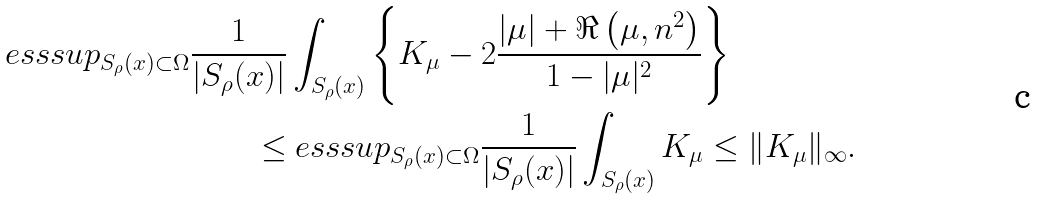<formula> <loc_0><loc_0><loc_500><loc_500>\ e s s s u p _ { S _ { \rho } ( x ) \subset \Omega } \frac { 1 } { | S _ { \rho } ( x ) | } & \int _ { S _ { \rho } ( x ) } \left \{ K _ { \mu } - 2 \frac { | \mu | + \Re \left ( \mu , n ^ { 2 } \right ) } { 1 - | \mu | ^ { 2 } } \right \} \\ \leq & \ e s s s u p _ { S _ { \rho } ( x ) \subset \Omega } \frac { 1 } { | S _ { \rho } ( x ) | } \int _ { S _ { \rho } ( x ) } K _ { \mu } \leq \| K _ { \mu } \| _ { \infty } .</formula> 